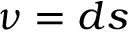<formula> <loc_0><loc_0><loc_500><loc_500>\nu = d s</formula> 